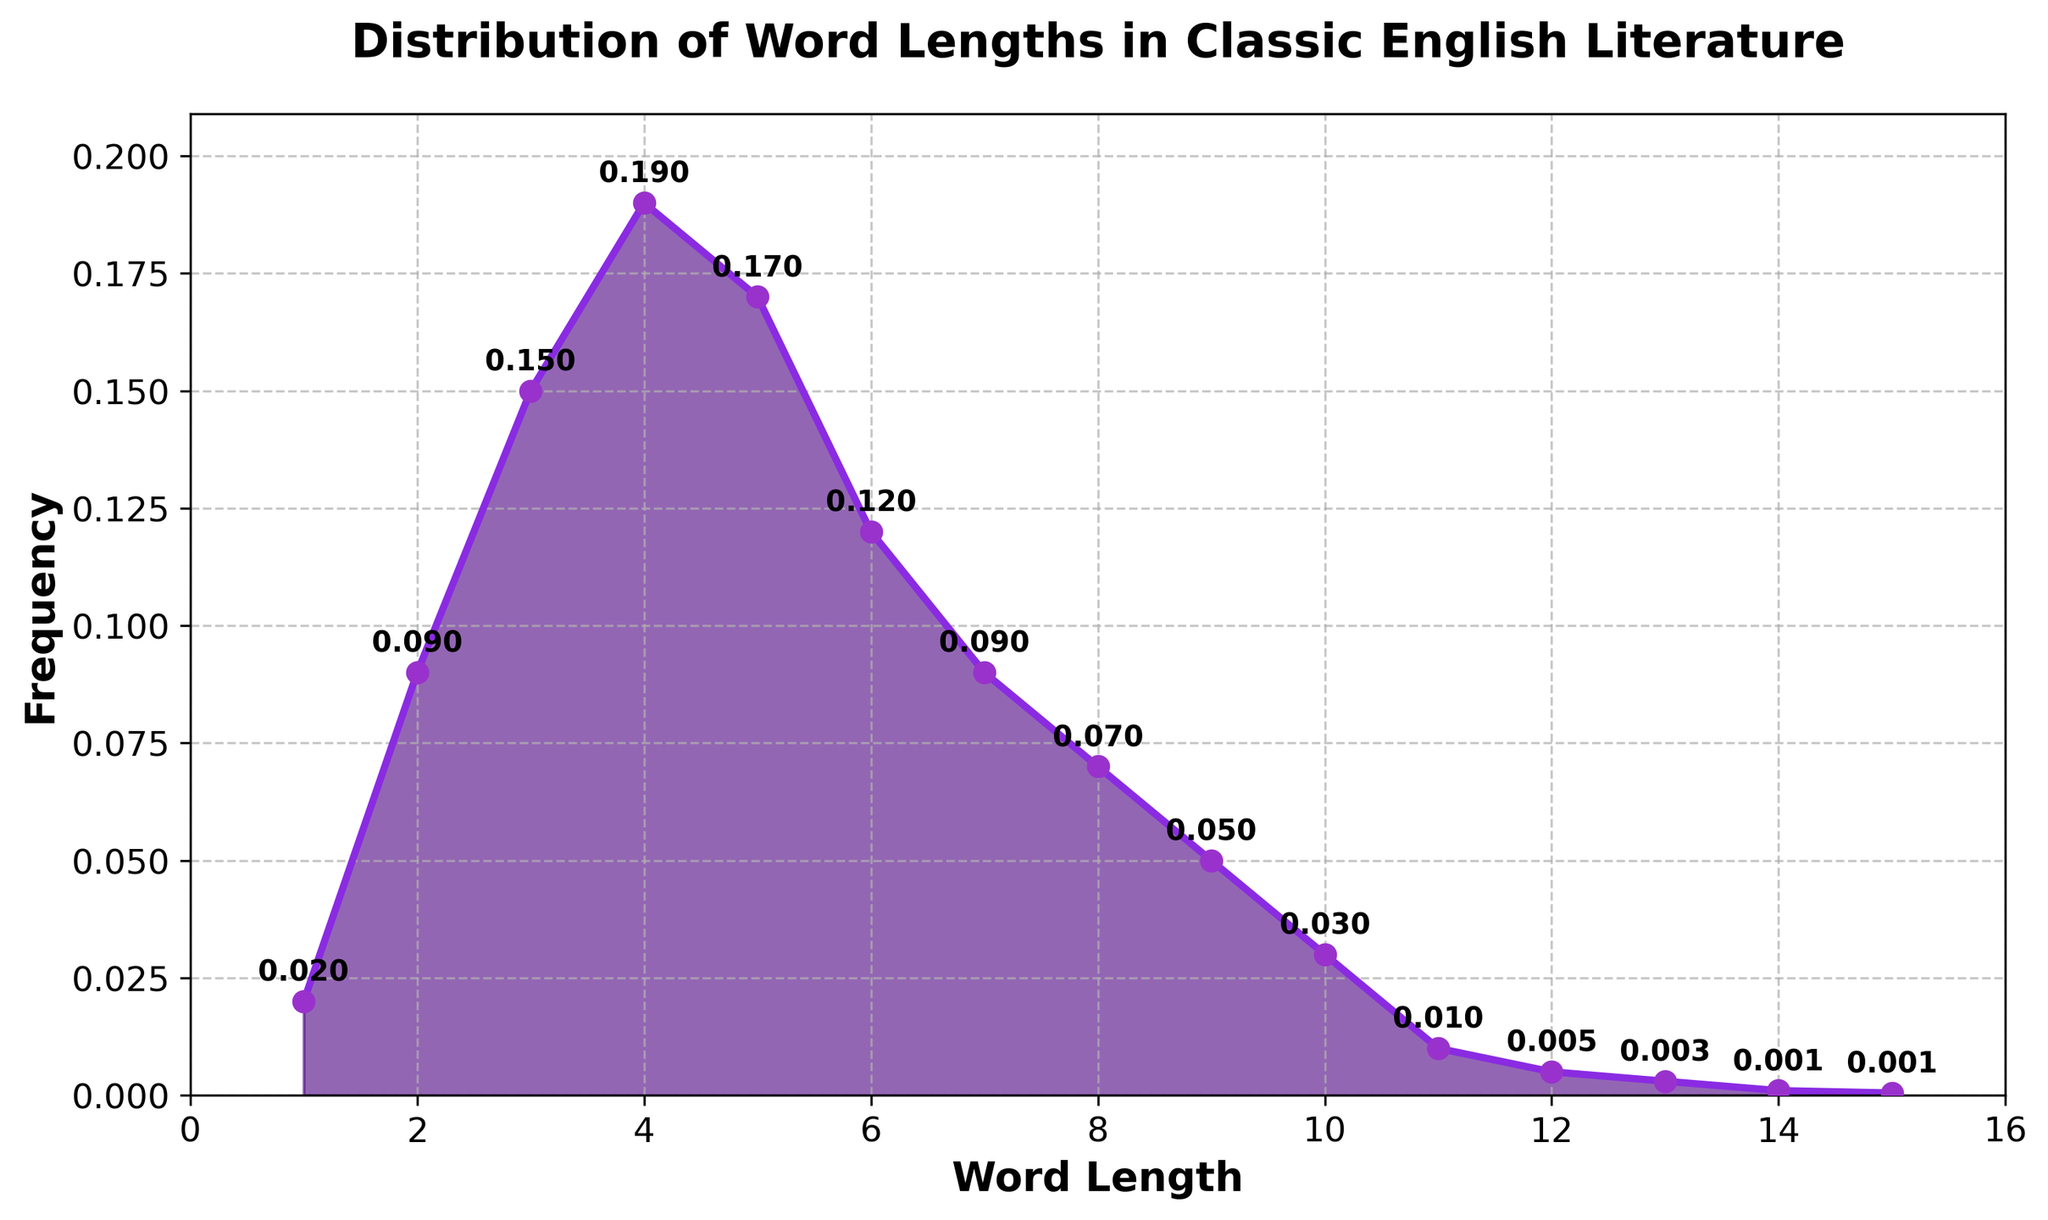What is the title of the plot? The title of the plot is displayed at the top of the figure in bold. It reads "Distribution of Word Lengths in Classic English Literature".
Answer: Distribution of Word Lengths in Classic English Literature What is the highest frequency value shown on the plot? The highest frequency value can be observed by looking for the tallest point on the plot's y-axis, which is 0.19, corresponding to a word length of 4.
Answer: 0.19 Which word length has the lowest frequency? The lowest frequency can be identified by looking at the lowest point on the y-axis, which is 0.0005 for the word length of 15.
Answer: 15 How many word lengths have a frequency of at least 0.1? By examining the y-axis values and counting the points, we see that word lengths 3, 4, 5, and 6 have frequencies of at least 0.1.
Answer: 4 Among word lengths 8, 9, and 10, which one has the highest frequency? To determine this, we compare the y-axis values for these word lengths: 0.07 (8), 0.05 (9), and 0.03 (10). The highest frequency is for the word length 8.
Answer: 8 What is the frequency difference between word lengths 4 and 7? The frequency of word length 4 is 0.19 and for word length 7 is 0.09. The difference is 0.19 - 0.09 = 0.10.
Answer: 0.10 What is the sum of frequencies for word lengths 1 to 3? The frequencies for word lengths 1, 2, and 3 are 0.02, 0.09, and 0.15, respectively. Summing these values: 0.02 + 0.09 + 0.15 = 0.26.
Answer: 0.26 How many data points represent word lengths greater than 10? By counting the points on the plot for word lengths 11 to 15, we find there are 5 such data points.
Answer: 5 Which word length has nearly twice the frequency of the word length 6? The frequency for word length 6 is 0.12. The word length with nearly twice this frequency (0.24) does not exactly exist, but the closest frequency is 0.19 for word length 4.
Answer: 4 